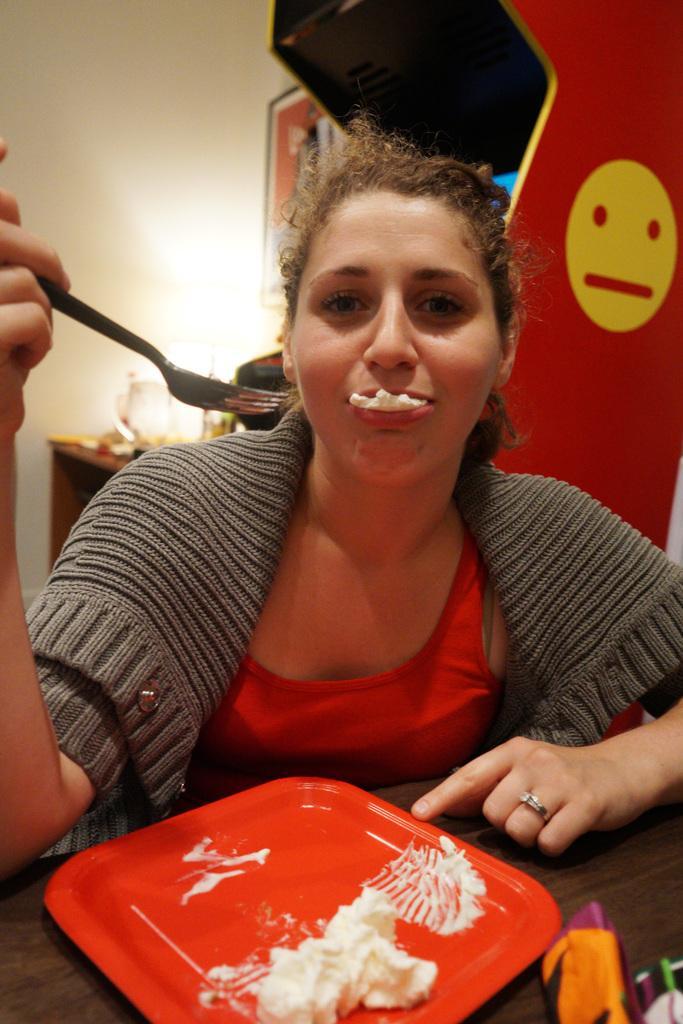Please provide a concise description of this image. In the foreground of the picture there is a woman holding a fork and eating food, in front of her there is a table, on the table there are plate, food item and other objects. In the background there are desk, jar, poster, wall, emoticon and other objects. 